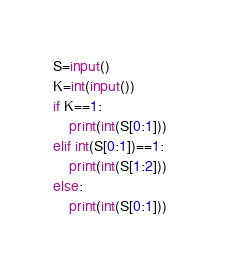<code> <loc_0><loc_0><loc_500><loc_500><_Python_>S=input()
K=int(input())
if K==1:
	print(int(S[0:1]))
elif int(S[0:1])==1:
	print(int(S[1:2]))
else:
	print(int(S[0:1]))	</code> 